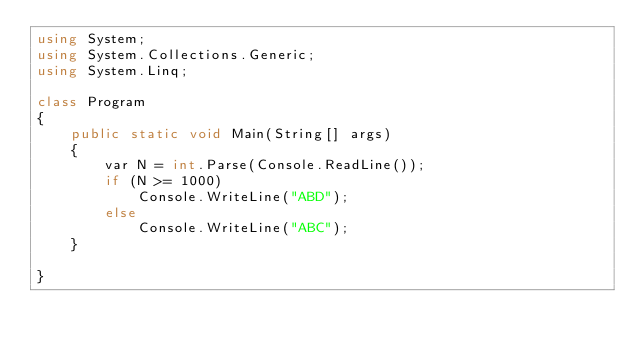Convert code to text. <code><loc_0><loc_0><loc_500><loc_500><_C#_>using System;
using System.Collections.Generic;
using System.Linq;

class Program
{
	public static void Main(String[] args)
	{
		var N = int.Parse(Console.ReadLine());
		if (N >= 1000)
			Console.WriteLine("ABD");
		else
			Console.WriteLine("ABC");
	}

}

</code> 